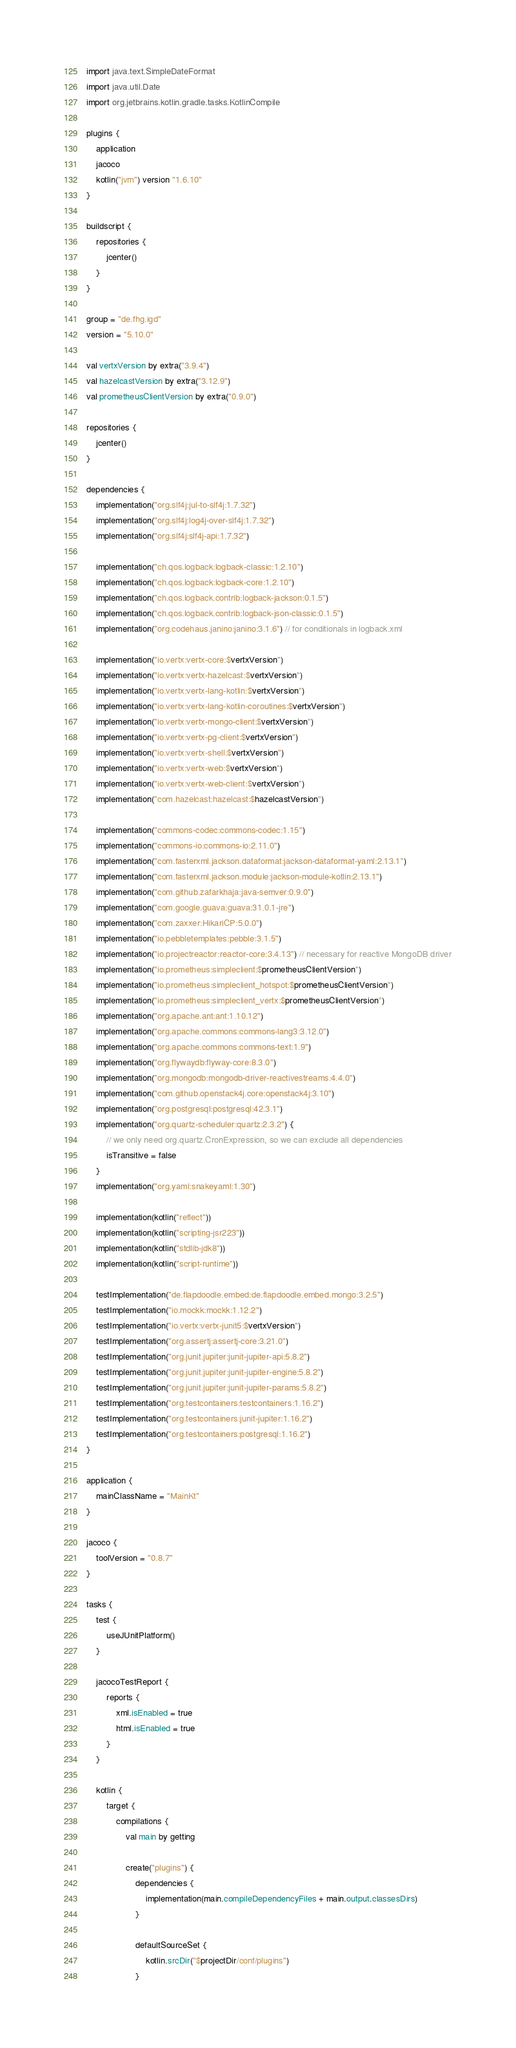Convert code to text. <code><loc_0><loc_0><loc_500><loc_500><_Kotlin_>import java.text.SimpleDateFormat
import java.util.Date
import org.jetbrains.kotlin.gradle.tasks.KotlinCompile

plugins {
    application
    jacoco
    kotlin("jvm") version "1.6.10"
}

buildscript {
    repositories {
        jcenter()
    }
}

group = "de.fhg.igd"
version = "5.10.0"

val vertxVersion by extra("3.9.4")
val hazelcastVersion by extra("3.12.9")
val prometheusClientVersion by extra("0.9.0")

repositories {
    jcenter()
}

dependencies {
    implementation("org.slf4j:jul-to-slf4j:1.7.32")
    implementation("org.slf4j:log4j-over-slf4j:1.7.32")
    implementation("org.slf4j:slf4j-api:1.7.32")

    implementation("ch.qos.logback:logback-classic:1.2.10")
    implementation("ch.qos.logback:logback-core:1.2.10")
    implementation("ch.qos.logback.contrib:logback-jackson:0.1.5")
    implementation("ch.qos.logback.contrib:logback-json-classic:0.1.5")
    implementation("org.codehaus.janino:janino:3.1.6") // for conditionals in logback.xml

    implementation("io.vertx:vertx-core:$vertxVersion")
    implementation("io.vertx:vertx-hazelcast:$vertxVersion")
    implementation("io.vertx:vertx-lang-kotlin:$vertxVersion")
    implementation("io.vertx:vertx-lang-kotlin-coroutines:$vertxVersion")
    implementation("io.vertx:vertx-mongo-client:$vertxVersion")
    implementation("io.vertx:vertx-pg-client:$vertxVersion")
    implementation("io.vertx:vertx-shell:$vertxVersion")
    implementation("io.vertx:vertx-web:$vertxVersion")
    implementation("io.vertx:vertx-web-client:$vertxVersion")
    implementation("com.hazelcast:hazelcast:$hazelcastVersion")

    implementation("commons-codec:commons-codec:1.15")
    implementation("commons-io:commons-io:2.11.0")
    implementation("com.fasterxml.jackson.dataformat:jackson-dataformat-yaml:2.13.1")
    implementation("com.fasterxml.jackson.module:jackson-module-kotlin:2.13.1")
    implementation("com.github.zafarkhaja:java-semver:0.9.0")
    implementation("com.google.guava:guava:31.0.1-jre")
    implementation("com.zaxxer:HikariCP:5.0.0")
    implementation("io.pebbletemplates:pebble:3.1.5")
    implementation("io.projectreactor:reactor-core:3.4.13") // necessary for reactive MongoDB driver
    implementation("io.prometheus:simpleclient:$prometheusClientVersion")
    implementation("io.prometheus:simpleclient_hotspot:$prometheusClientVersion")
    implementation("io.prometheus:simpleclient_vertx:$prometheusClientVersion")
    implementation("org.apache.ant:ant:1.10.12")
    implementation("org.apache.commons:commons-lang3:3.12.0")
    implementation("org.apache.commons:commons-text:1.9")
    implementation("org.flywaydb:flyway-core:8.3.0")
    implementation("org.mongodb:mongodb-driver-reactivestreams:4.4.0")
    implementation("com.github.openstack4j.core:openstack4j:3.10")
    implementation("org.postgresql:postgresql:42.3.1")
    implementation("org.quartz-scheduler:quartz:2.3.2") {
        // we only need org.quartz.CronExpression, so we can exclude all dependencies
        isTransitive = false
    }
    implementation("org.yaml:snakeyaml:1.30")

    implementation(kotlin("reflect"))
    implementation(kotlin("scripting-jsr223"))
    implementation(kotlin("stdlib-jdk8"))
    implementation(kotlin("script-runtime"))

    testImplementation("de.flapdoodle.embed:de.flapdoodle.embed.mongo:3.2.5")
    testImplementation("io.mockk:mockk:1.12.2")
    testImplementation("io.vertx:vertx-junit5:$vertxVersion")
    testImplementation("org.assertj:assertj-core:3.21.0")
    testImplementation("org.junit.jupiter:junit-jupiter-api:5.8.2")
    testImplementation("org.junit.jupiter:junit-jupiter-engine:5.8.2")
    testImplementation("org.junit.jupiter:junit-jupiter-params:5.8.2")
    testImplementation("org.testcontainers:testcontainers:1.16.2")
    testImplementation("org.testcontainers:junit-jupiter:1.16.2")
    testImplementation("org.testcontainers:postgresql:1.16.2")
}

application {
    mainClassName = "MainKt"
}

jacoco {
    toolVersion = "0.8.7"
}

tasks {
    test {
        useJUnitPlatform()
    }

    jacocoTestReport {
        reports {
            xml.isEnabled = true
            html.isEnabled = true
        }
    }

    kotlin {
        target {
            compilations {
                val main by getting

                create("plugins") {
                    dependencies {
                        implementation(main.compileDependencyFiles + main.output.classesDirs)
                    }

                    defaultSourceSet {
                        kotlin.srcDir("$projectDir/conf/plugins")
                    }</code> 